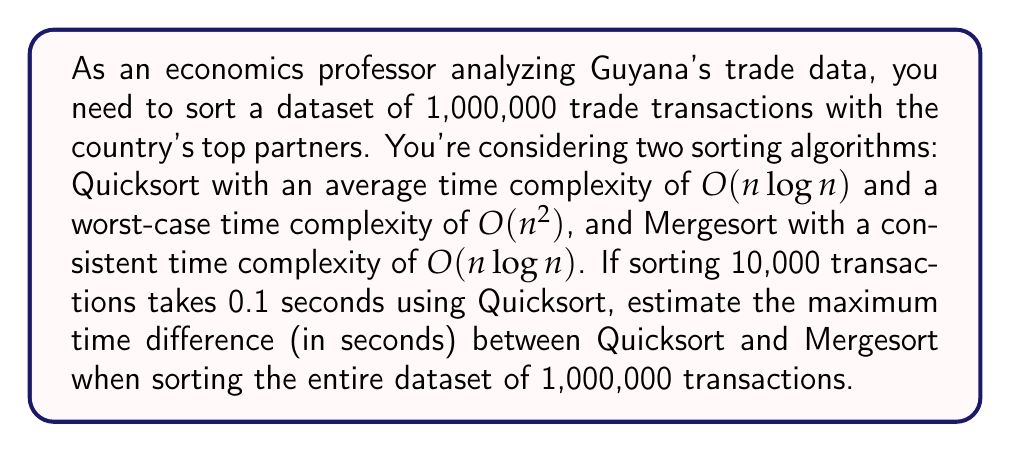Show me your answer to this math problem. To solve this problem, we need to follow these steps:

1) First, let's establish the time complexity ratio between 1,000,000 and 10,000 transactions for both algorithms.

   For Quicksort (worst-case):
   $$\frac{T(1,000,000)}{T(10,000)} = \frac{1,000,000^2}{10,000^2} = 10,000$$

   For Mergesort:
   $$\frac{T(1,000,000)}{T(10,000)} = \frac{1,000,000 \log(1,000,000)}{10,000 \log(10,000)} \approx 150$$

2) Now, we know that Quicksort takes 0.1 seconds for 10,000 transactions. Let's calculate the worst-case time for 1,000,000 transactions:

   $$0.1 \text{ seconds} \times 10,000 = 1,000 \text{ seconds}$$

3) For Mergesort, we can calculate the time for 1,000,000 transactions:

   $$0.1 \text{ seconds} \times 150 = 15 \text{ seconds}$$

4) The maximum time difference would be when Quicksort performs at its worst-case complexity and Mergesort at its average (which is also its worst-case):

   $$1,000 \text{ seconds} - 15 \text{ seconds} = 985 \text{ seconds}$$
Answer: The maximum time difference between Quicksort and Mergesort when sorting 1,000,000 trade transactions is 985 seconds. 